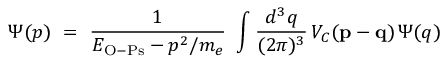Convert formula to latex. <formula><loc_0><loc_0><loc_500><loc_500>\Psi ( p ) = { \frac { 1 } { E _ { O - P s } - p ^ { 2 } / m _ { e } } } \int { \frac { d ^ { 3 } q } { ( 2 \pi ) ^ { 3 } } } \, V _ { C } ( { p } - { q } ) \, \Psi ( q )</formula> 